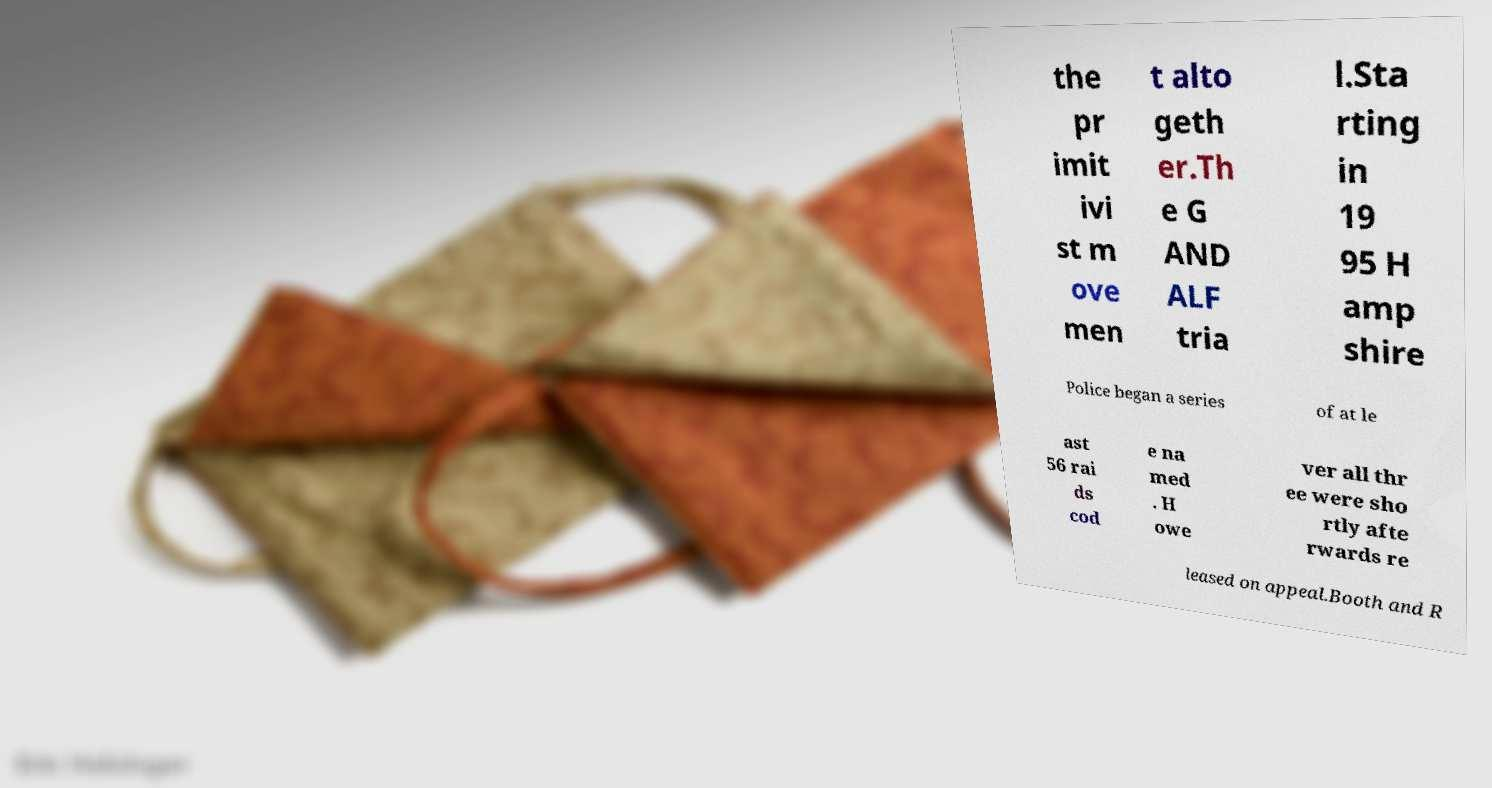Can you accurately transcribe the text from the provided image for me? the pr imit ivi st m ove men t alto geth er.Th e G AND ALF tria l.Sta rting in 19 95 H amp shire Police began a series of at le ast 56 rai ds cod e na med . H owe ver all thr ee were sho rtly afte rwards re leased on appeal.Booth and R 